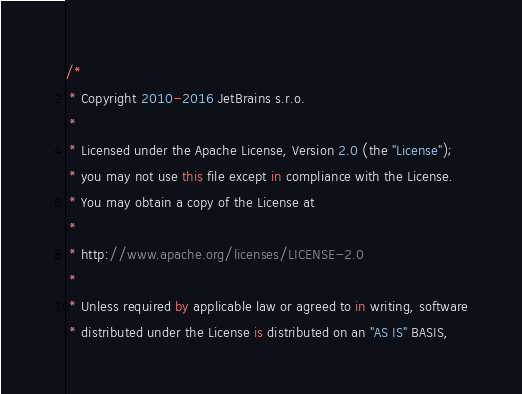Convert code to text. <code><loc_0><loc_0><loc_500><loc_500><_Kotlin_>/*
 * Copyright 2010-2016 JetBrains s.r.o.
 *
 * Licensed under the Apache License, Version 2.0 (the "License");
 * you may not use this file except in compliance with the License.
 * You may obtain a copy of the License at
 *
 * http://www.apache.org/licenses/LICENSE-2.0
 *
 * Unless required by applicable law or agreed to in writing, software
 * distributed under the License is distributed on an "AS IS" BASIS,</code> 